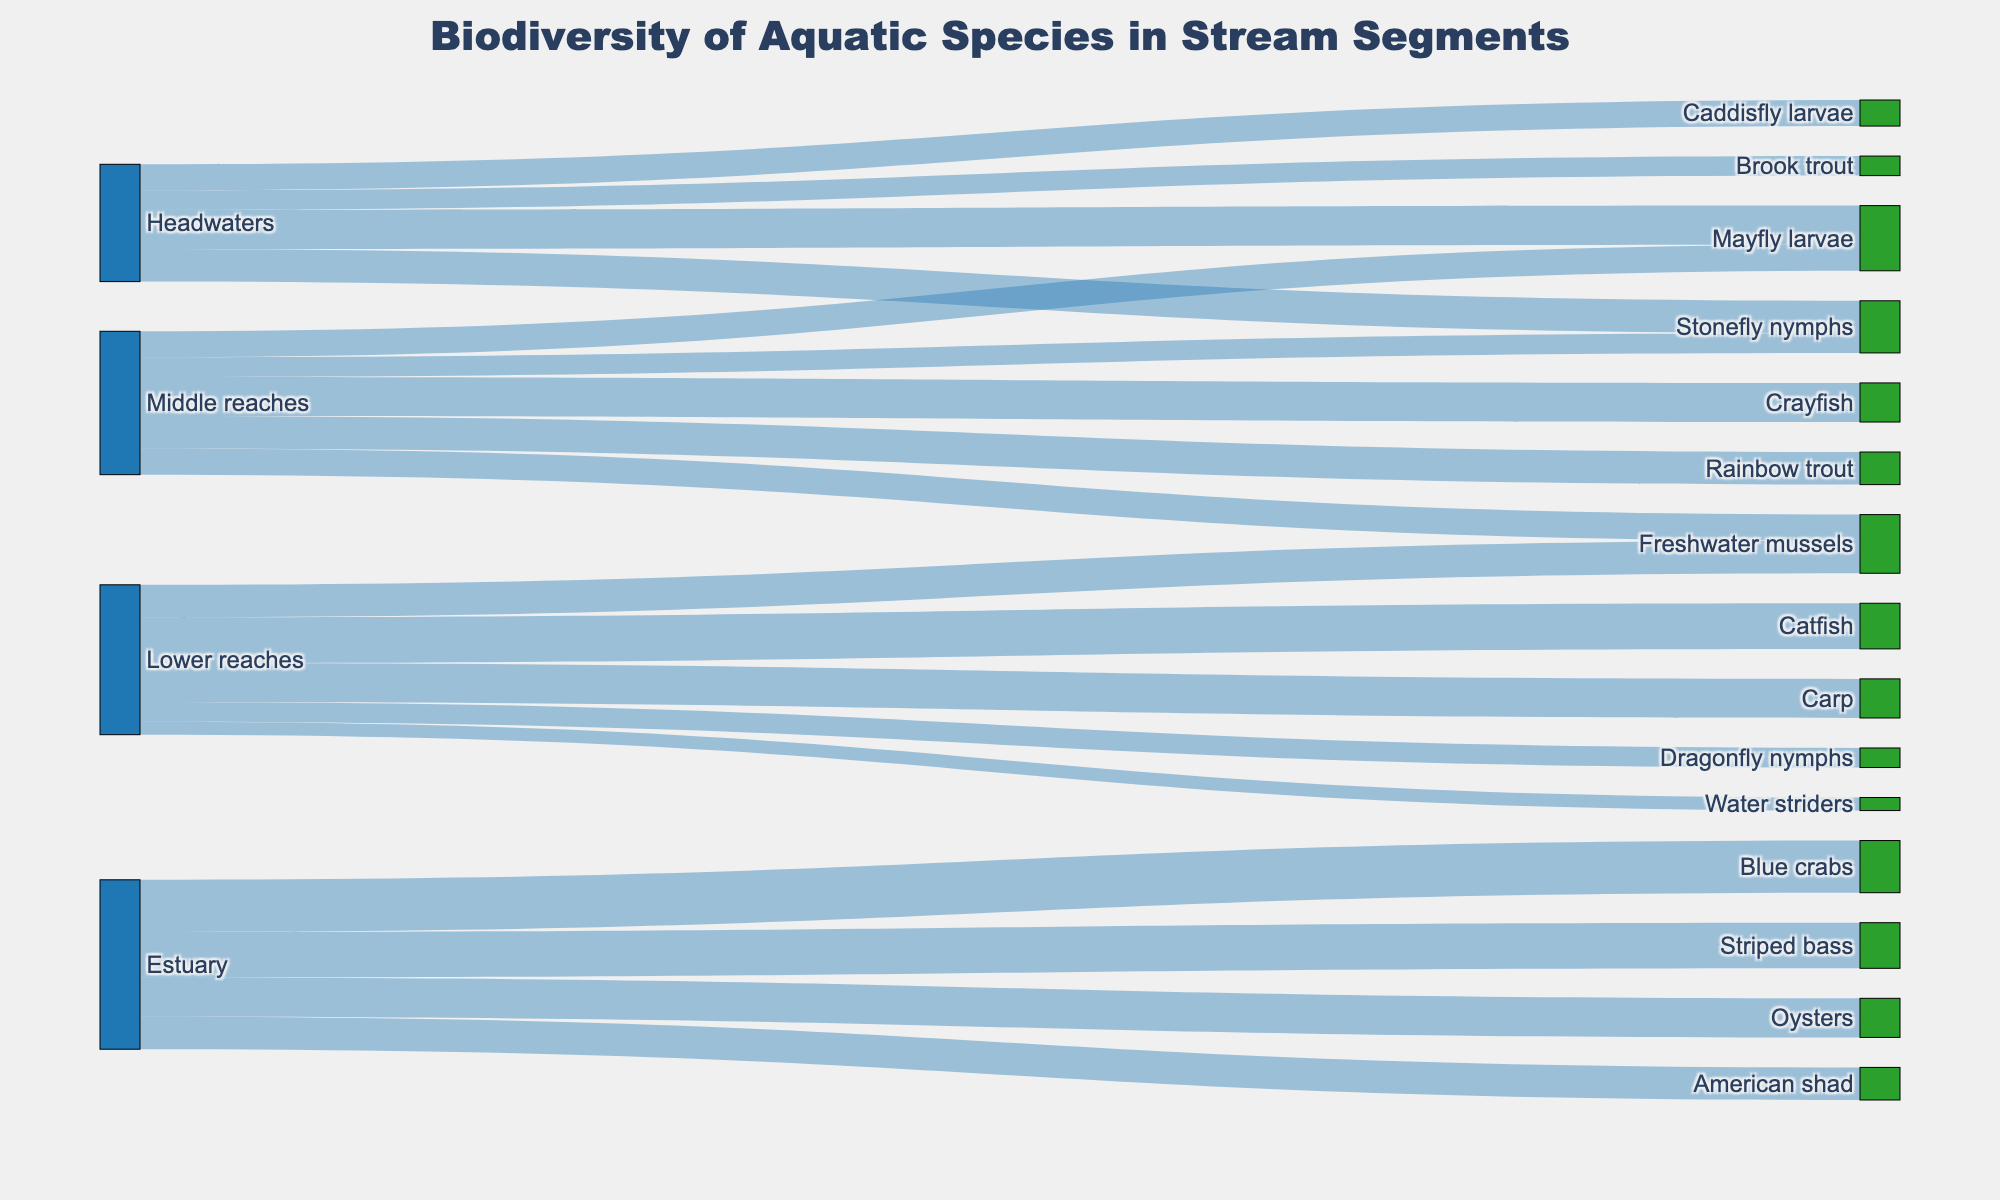what is the title of the plot? The title is usually located at the top of the plot. It clearly states what the figure is about.
Answer: Biodiversity of Aquatic Species in Stream Segments how many unique stream segments are there in the diagram? The unique stream segments can be seen as the sources in the Sankey diagram. Count the unique names in the source column.
Answer: 4 which stream segment has the highest number of species? Look at the Sankey diagram and see which source has the most outgoing flows to different species (targets).
Answer: Lower reaches what is the total value of aquatic species in the Headwaters segment? Sum up the values associated with the Headwaters segment by adding 30 (Mayfly larvae) + 25 (Stonefly nymphs) + 15 (Brook trout) + 20 (Caddisfly larvae).
Answer: 90 compare the number of species between Middle reaches and Lower reaches. which one has more? Count the unique targets for both Middle reaches (Mayfly larvae, Stonefly nymphs, Rainbow trout, Crayfish, Freshwater mussels) and Lower reaches (Catfish, Carp, Dragonfly nymphs, Freshwater mussels, Water striders). Each has 5, so they are equal.
Answer: equal which species has the largest value overall? Look at all of the target nodes and compare the values associated with each to find the largest.
Answer: Blue crabs how do the values for Freshwater mussels in Middle reaches compare to the values in Lower reaches? Look at the value for Freshwater mussels in both Middle reaches (20) and Lower reaches (25). Then, compare the two values.
Answer: 25 is larger than 20 what is the combined value of Rainbow trout and Brook trout? Add the value of Rainbow trout (25) and Brook trout (15): 25 + 15 = 40.
Answer: 40 which species appear in multiple stream segments? Check the target nodes and see which names appear more than once. Freshwater mussels appear in both Middle reaches and Lower reaches.
Answer: Freshwater mussels calculate the difference in value between Catfish and Carp in the Lower reaches. Subtract the value of Carp (30) from the value of Catfish (35): 35 - 30 = 5.
Answer: 5 